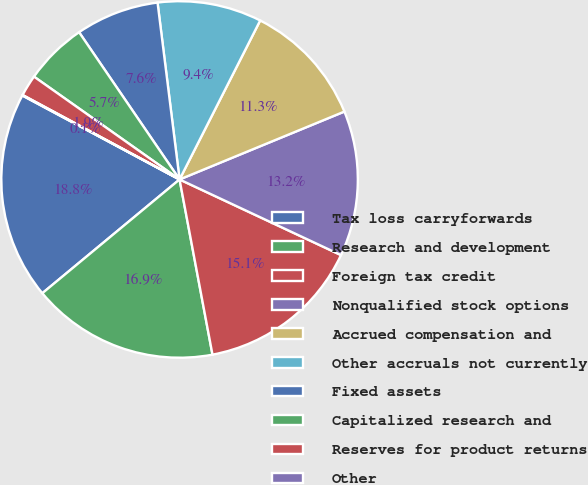<chart> <loc_0><loc_0><loc_500><loc_500><pie_chart><fcel>Tax loss carryforwards<fcel>Research and development<fcel>Foreign tax credit<fcel>Nonqualified stock options<fcel>Accrued compensation and<fcel>Other accruals not currently<fcel>Fixed assets<fcel>Capitalized research and<fcel>Reserves for product returns<fcel>Other<nl><fcel>18.82%<fcel>16.94%<fcel>15.07%<fcel>13.19%<fcel>11.31%<fcel>9.44%<fcel>7.56%<fcel>5.68%<fcel>1.93%<fcel>0.05%<nl></chart> 